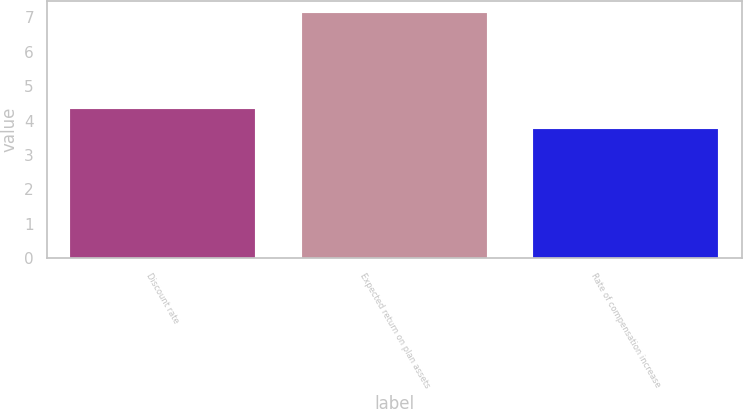<chart> <loc_0><loc_0><loc_500><loc_500><bar_chart><fcel>Discount rate<fcel>Expected return on plan assets<fcel>Rate of compensation increase<nl><fcel>4.35<fcel>7.12<fcel>3.75<nl></chart> 